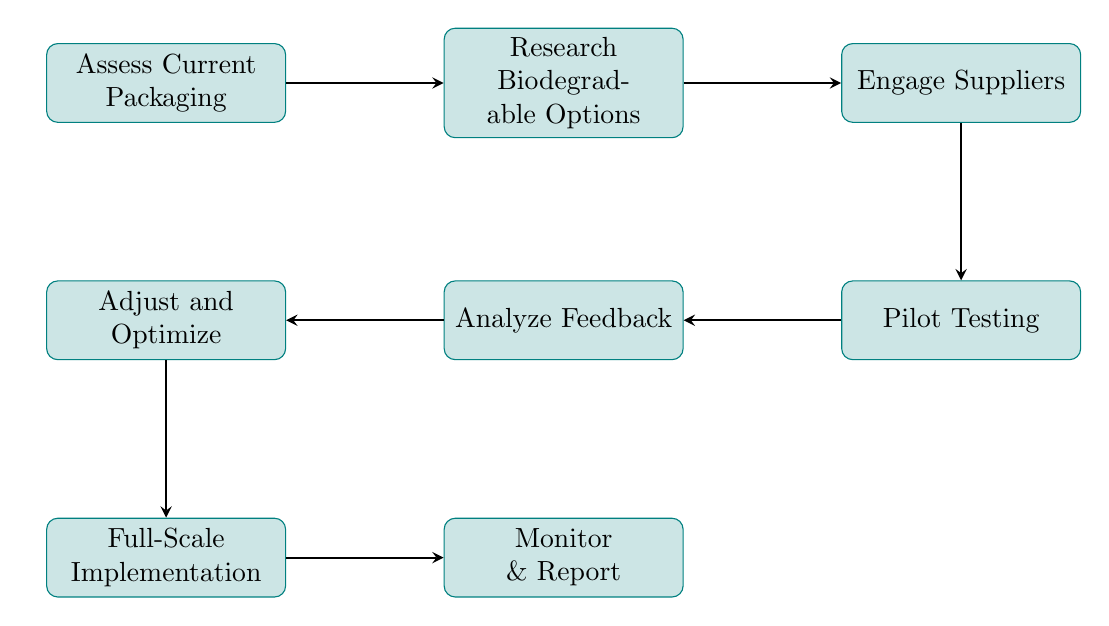What is the first step in the transition plan? The first step in the diagram is labeled as "Assess Current Packaging." This can be identified as the starting node in the flow chart.
Answer: Assess Current Packaging How many nodes are in the diagram? By counting each distinct step or process represented within the diagram, we find that there are eight nodes in total.
Answer: 8 What follows "Pilot Testing"? After "Pilot Testing," the next step in the flow is "Analyze Feedback." This relationship can be followed directly along the arrows connecting the nodes.
Answer: Analyze Feedback Which step includes engaging with suppliers? The step that involves engaging with suppliers is labeled "Engage Suppliers." This node is directly connected to the research step that precedes it.
Answer: Engage Suppliers What is the final step of the transition plan? The last step in the transition plan, as represented by the endpoint of the flow chart, is "Monitor & Report." This indicates the ongoing evaluation phase after full implementation.
Answer: Monitor & Report What is the relationship between "Analyze Feedback" and "Adjust and Optimize"? The relationship is that "Analyze Feedback" leads to "Adjust and Optimize," as seen in the directional arrow connecting these two nodes in the diagram.
Answer: Adjusts to What is the purpose of the "Pilot Testing" step? The "Pilot Testing" step is designed to test selected biodegradable packaging in specific stores, which is indicated in the description of that node.
Answer: Test selected biodegradable packaging What step comes before "Full-Scale Implementation"? The step that occurs immediately before "Full-Scale Implementation" is "Adjust and Optimize," meaning revisions based on previous feedback should occur before the overall rollout.
Answer: Adjust and Optimize 